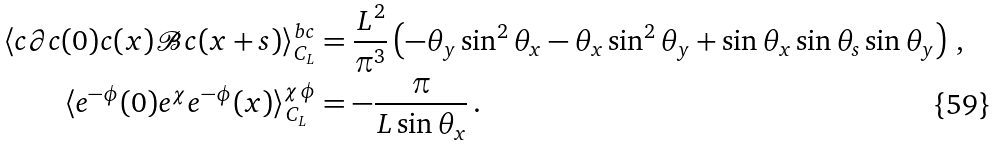Convert formula to latex. <formula><loc_0><loc_0><loc_500><loc_500>\langle c \partial c ( 0 ) c ( x ) \mathcal { B } c ( x + s ) \rangle ^ { b c } _ { C _ { L } } & = \frac { L ^ { 2 } } { \pi ^ { 3 } } \left ( - \theta _ { y } \sin ^ { 2 } \theta _ { x } - \theta _ { x } \sin ^ { 2 } \theta _ { y } + \sin \theta _ { x } \sin \theta _ { s } \sin \theta _ { y } \right ) \, , \\ \langle e ^ { - \phi } ( 0 ) e ^ { \chi } e ^ { - \phi } ( x ) \rangle ^ { \chi \phi } _ { C _ { L } } & = - \frac { \pi } { L \sin \theta _ { x } } \, .</formula> 